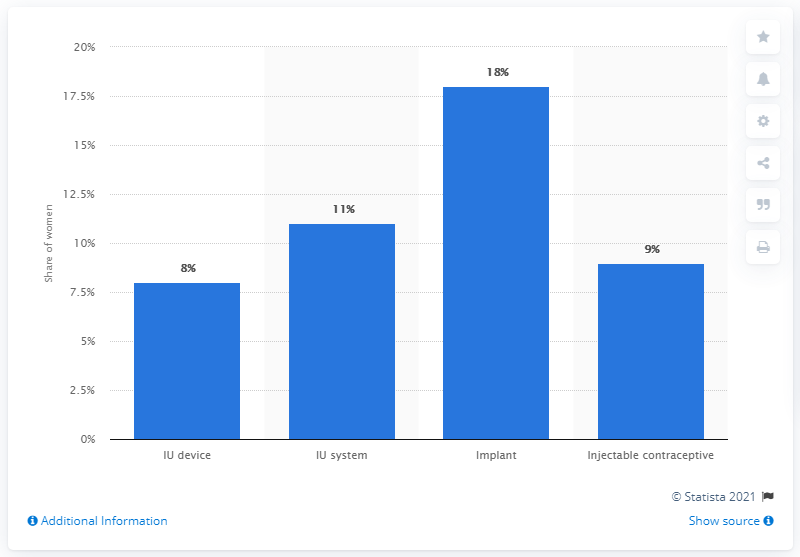Specify some key components in this picture. According to data from 2019/20, it is estimated that approximately 18% of women in England have an implant device. According to recent statistics, a significant percentage of women in England use the intrauterine system. 